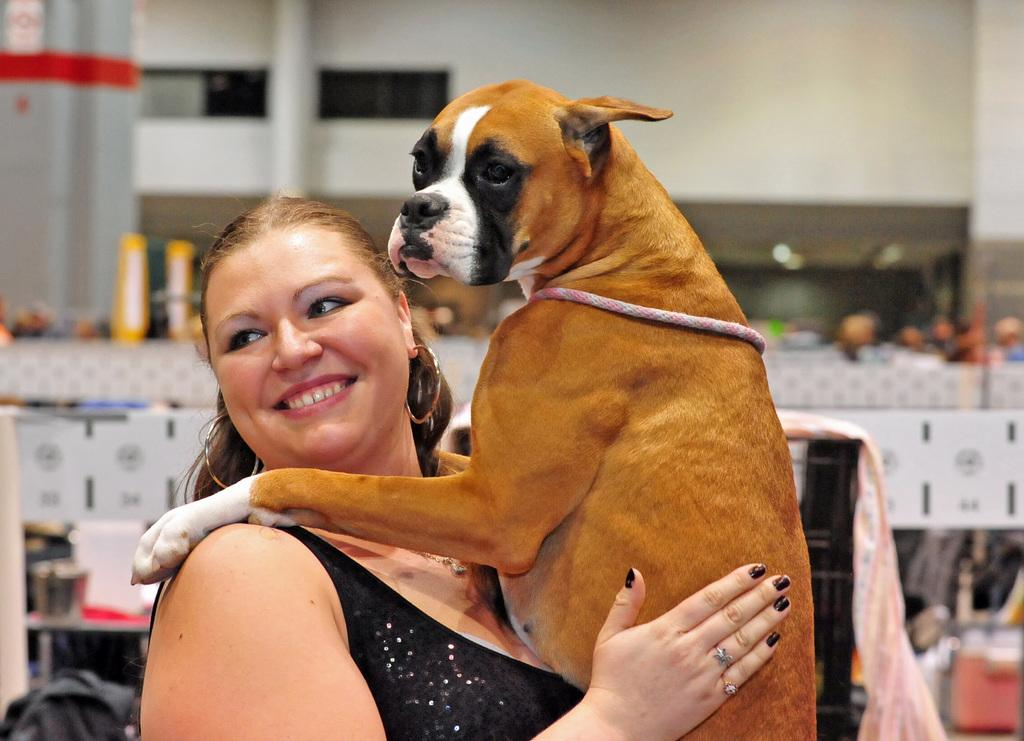Who is present in the image? There is a woman in the image. What is the woman doing with the dog? The woman is holding a dog in the image. What is the woman's facial expression? The woman is smiling in the image. What can be seen on the right side of the image? There is a group of people sitting on the right side of the image. What is visible at the top of the image? There is a wall at the top of the image. How many children are sitting at the table in the image? There is no table present in the image, and therefore no children can be observed sitting at a table. 